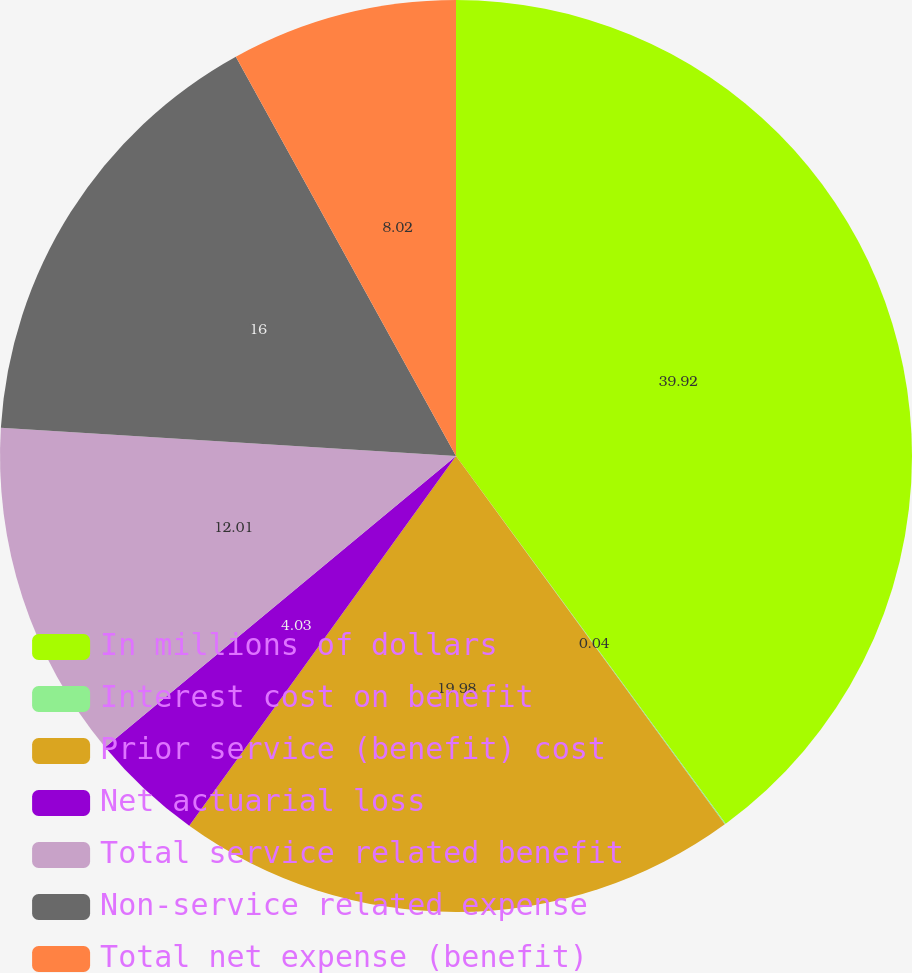Convert chart to OTSL. <chart><loc_0><loc_0><loc_500><loc_500><pie_chart><fcel>In millions of dollars<fcel>Interest cost on benefit<fcel>Prior service (benefit) cost<fcel>Net actuarial loss<fcel>Total service related benefit<fcel>Non-service related expense<fcel>Total net expense (benefit)<nl><fcel>39.93%<fcel>0.04%<fcel>19.98%<fcel>4.03%<fcel>12.01%<fcel>16.0%<fcel>8.02%<nl></chart> 